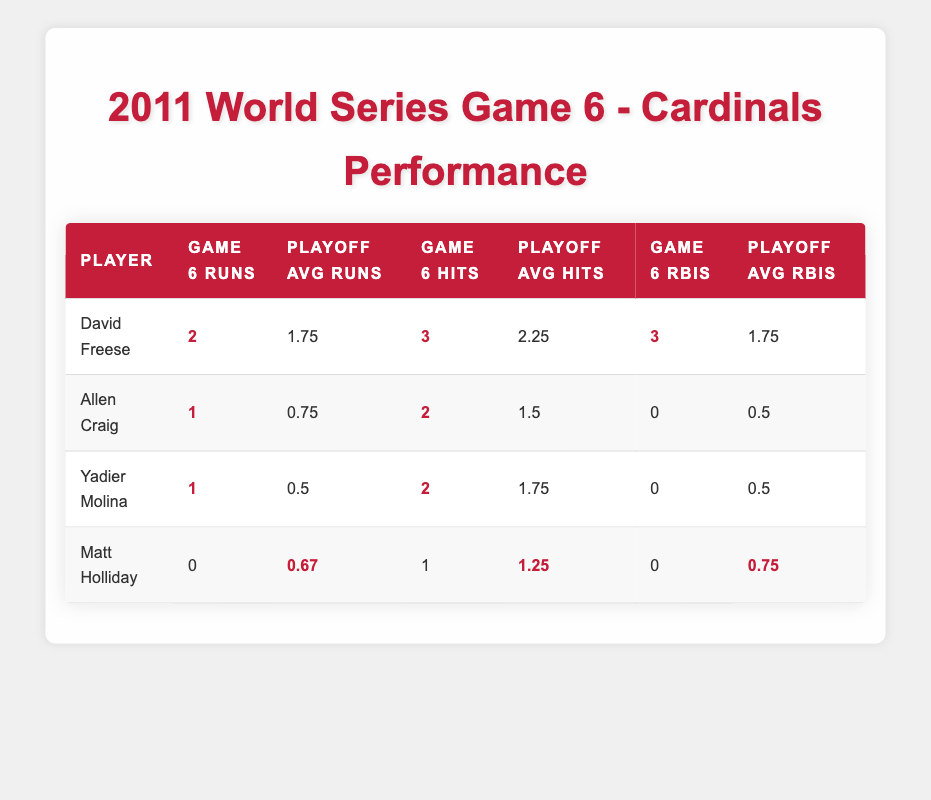What is David Freese's batting average in Game 6 of the 2011 World Series? The table shows that David Freese's batting average in Game 6 is highlighted and listed as 1.000.
Answer: 1.000 How many RBIs did Yadier Molina have in Game 6? Yadier Molina's RBIs in Game 6 are given in the table, and they are highlighted as 0.
Answer: 0 Which player had the highest average runs in other playoff games? By comparing the average runs in the "Playoff Avg Runs" column for each player in the "Other Playoff Games", Matt Carpenter has the highest average at 2.
Answer: 2 What was David Freese's RBIs in Game 6 compared to his playoff average? In Game 6, Freese had 3 RBIs highlighted, and his playoff average RBIs are shown as 1.75. The difference indicates he performed better in Game 6.
Answer: 3 RBIs Did Allen Craig score more runs in Game 6 or in his average across other playoff games? Craig scored 1 run in Game 6, while his playoff average runs are 0.75. This means he scored more in Game 6 than his average in other games.
Answer: Yes What is the total number of hits by David Freese and Allen Craig in Game 6? The table shows that Freese had 3 hits and Craig had 2 hits. Adding these together (3 + 2) results in a total of 5 hits.
Answer: 5 Which player had a higher batting average in Game 6, Freese or Molina? Freese's batting average is shown as 1.000 and Molina's as 0.667. Since 1.000 is greater than 0.667, Freese had the higher average.
Answer: Freese Calculate the difference in RBIs between David Freese's Game 6 performance and his playoff average. Freese's RBIs in Game 6 were 3 and his playoff average was 1.75. The difference (3 - 1.75) equals 1.25, indicating his significant performance in Game 6.
Answer: 1.25 Did any player score no runs in both Game 6 and their average playoff games? Matt Holliday scored 0 runs in Game 6 and has an average of 0.67 runs, which means he did not score any runs in Game 6 specifically.
Answer: Yes Who had the highest batting average in Game 6 among the players listed? The highest batting average for the listed players in Game 6 is David Freese at 1.000, while the others (Craig, Molina, Holliday) have lower averages.
Answer: David Freese 